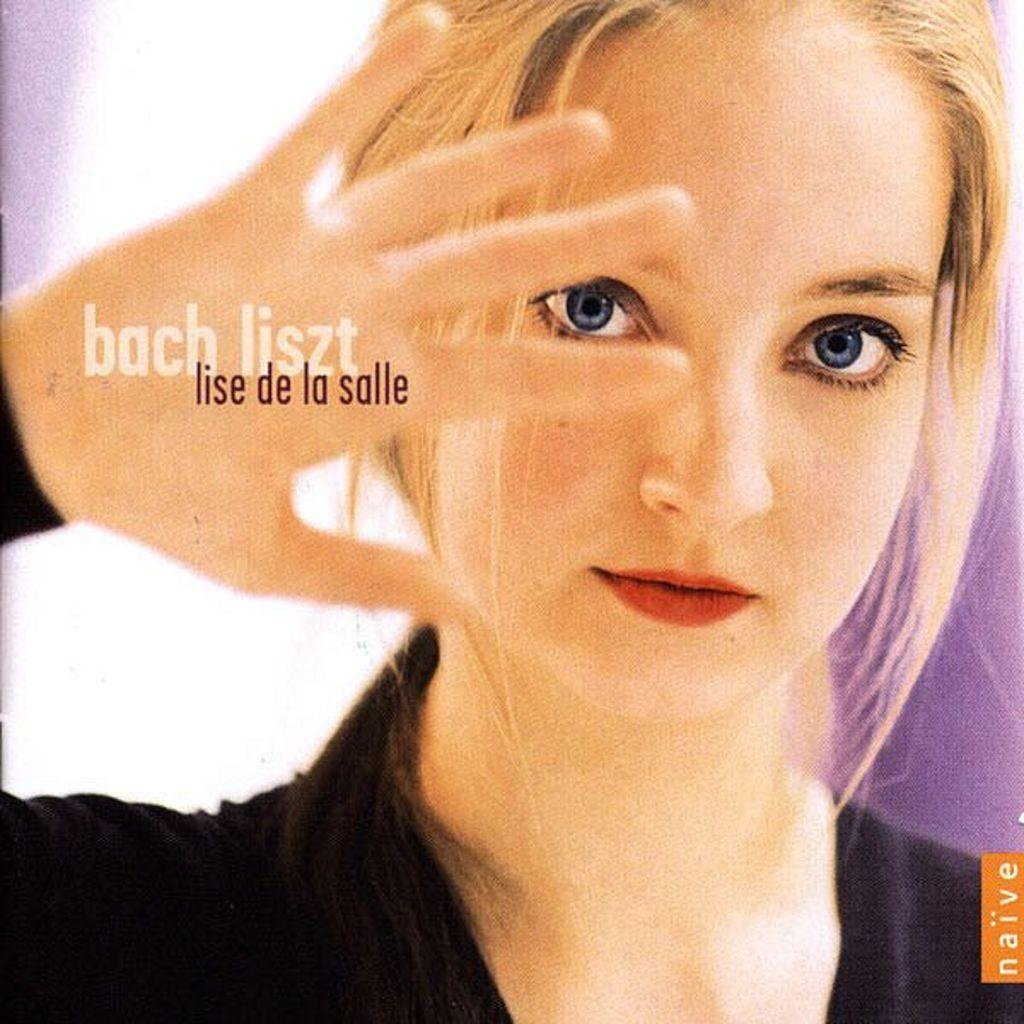Who is the main subject in the image? There is a girl in the image. What is the girl wearing? The girl is wearing a black dress. Can you describe any additional details about the girl? There is text visible on the girl's hand. Is the girl riding a bike in the image? No, there is no bike present in the image. What type of front can be seen in the image? There is no specific "front" mentioned in the image; it is a picture of a girl with text on her hand. 